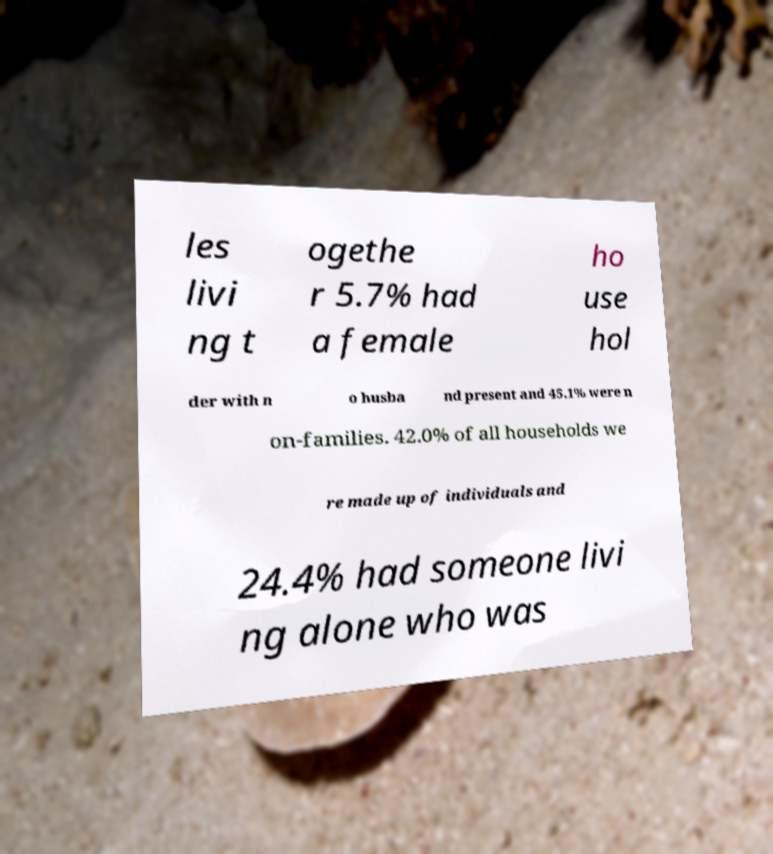Please identify and transcribe the text found in this image. les livi ng t ogethe r 5.7% had a female ho use hol der with n o husba nd present and 45.1% were n on-families. 42.0% of all households we re made up of individuals and 24.4% had someone livi ng alone who was 